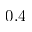Convert formula to latex. <formula><loc_0><loc_0><loc_500><loc_500>0 . 4</formula> 